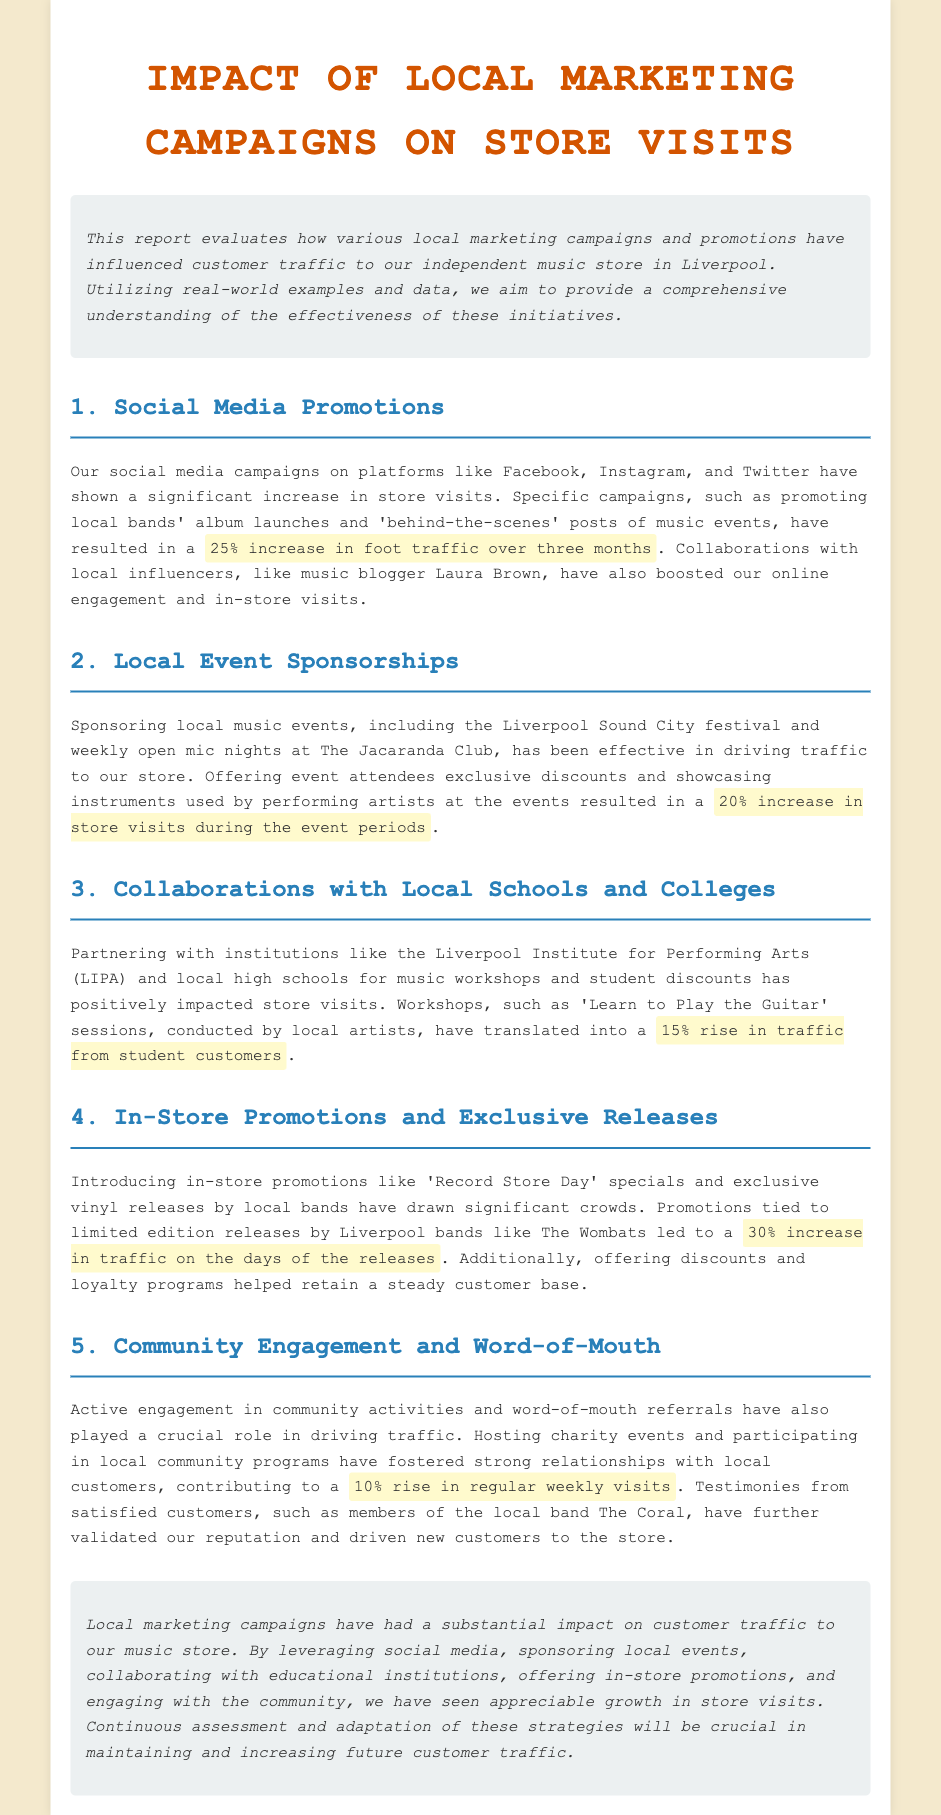what was the percentage increase in foot traffic from social media campaigns? The document states that social media promotions resulted in a 25% increase in foot traffic over three months.
Answer: 25% what local music event was mentioned as being sponsored? The report mentions sponsoring the Liverpool Sound City festival.
Answer: Liverpool Sound City festival what is the percentage rise in traffic from student customers due to collaborations with local schools? The report highlights a 15% rise in traffic from student customers due to workshops.
Answer: 15% what type of promotions led to a 30% increase in traffic? The document specifies that in-store promotions like 'Record Store Day' specials and exclusive releases led to a 30% increase in traffic.
Answer: Record Store Day what customer base aspect was mentioned as being influenced by community engagement? The document mentions that community engagement contributed to a 10% rise in regular weekly visits.
Answer: 10% which local band's members provided testimonies that validated the store's reputation? The report specifically mentions members of the local band The Coral.
Answer: The Coral what was the cumulative effect of local marketing campaigns on store visits described in the conclusion? The conclusion states there has been appreciable growth in store visits due to various local marketing campaigns.
Answer: appreciable growth who collaborated with the store for music workshops? The report lists local institutions like the Liverpool Institute for Performing Arts (LIPA).
Answer: Liverpool Institute for Performing Arts (LIPA) how does the report suggest maintaining and increasing future customer traffic? The report advises continuous assessment and adaptation of marketing strategies.
Answer: continuous assessment and adaptation 